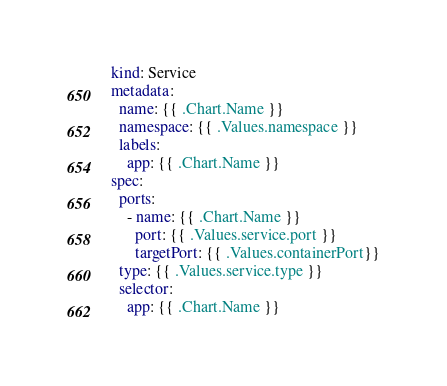Convert code to text. <code><loc_0><loc_0><loc_500><loc_500><_YAML_>kind: Service
metadata:
  name: {{ .Chart.Name }}
  namespace: {{ .Values.namespace }}
  labels:
    app: {{ .Chart.Name }}
spec:
  ports:
    - name: {{ .Chart.Name }}
      port: {{ .Values.service.port }}
      targetPort: {{ .Values.containerPort}}
  type: {{ .Values.service.type }}
  selector:
    app: {{ .Chart.Name }}</code> 